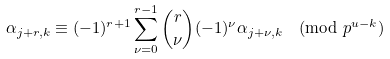Convert formula to latex. <formula><loc_0><loc_0><loc_500><loc_500>\alpha _ { j + r , k } \equiv ( - 1 ) ^ { r + 1 } \sum _ { \nu = 0 } ^ { r - 1 } \binom { r } { \nu } ( - 1 ) ^ { \nu } \alpha _ { j + \nu , k } \pmod { p ^ { u - k } }</formula> 